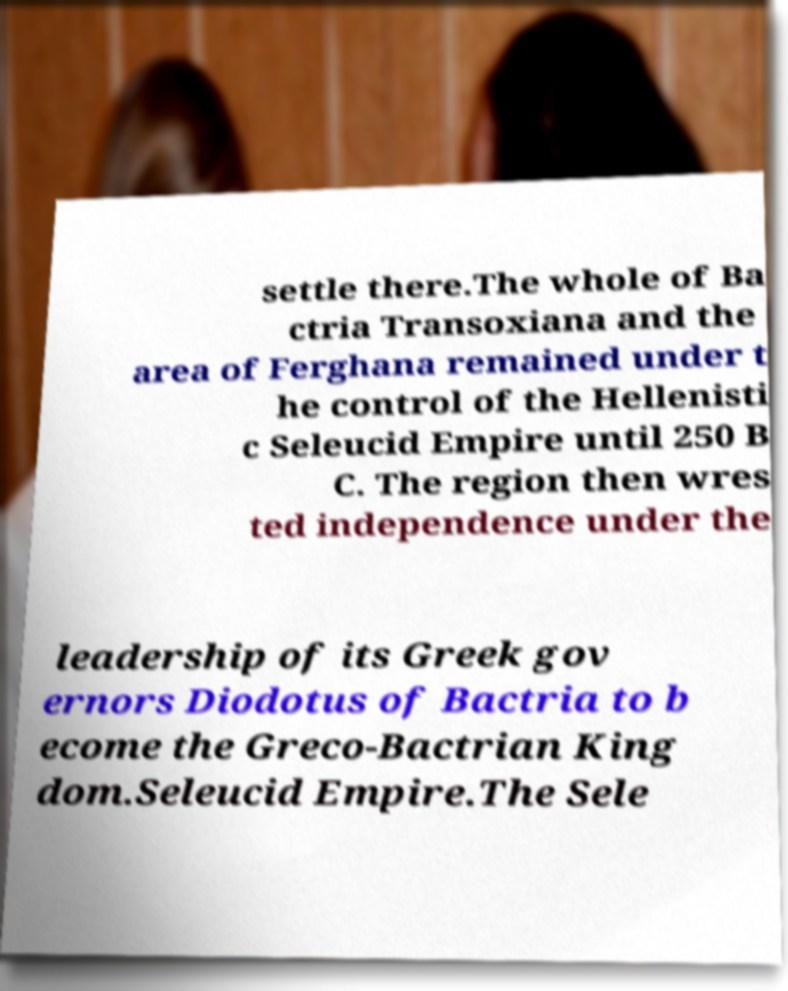Please identify and transcribe the text found in this image. settle there.The whole of Ba ctria Transoxiana and the area of Ferghana remained under t he control of the Hellenisti c Seleucid Empire until 250 B C. The region then wres ted independence under the leadership of its Greek gov ernors Diodotus of Bactria to b ecome the Greco-Bactrian King dom.Seleucid Empire.The Sele 